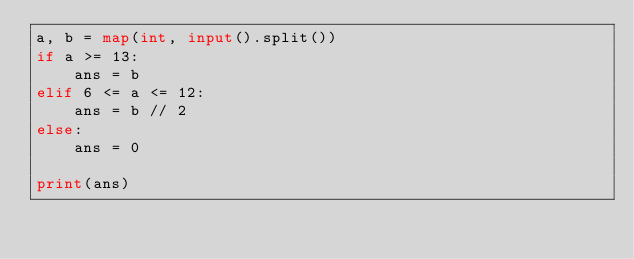Convert code to text. <code><loc_0><loc_0><loc_500><loc_500><_Python_>a, b = map(int, input().split())
if a >= 13:
    ans = b
elif 6 <= a <= 12:
    ans = b // 2
else:
    ans = 0

print(ans)
</code> 